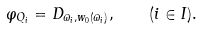Convert formula to latex. <formula><loc_0><loc_0><loc_500><loc_500>\varphi _ { Q _ { i } } = D _ { \varpi _ { i } , w _ { 0 } ( \varpi _ { i } ) } , \quad ( i \in I ) .</formula> 